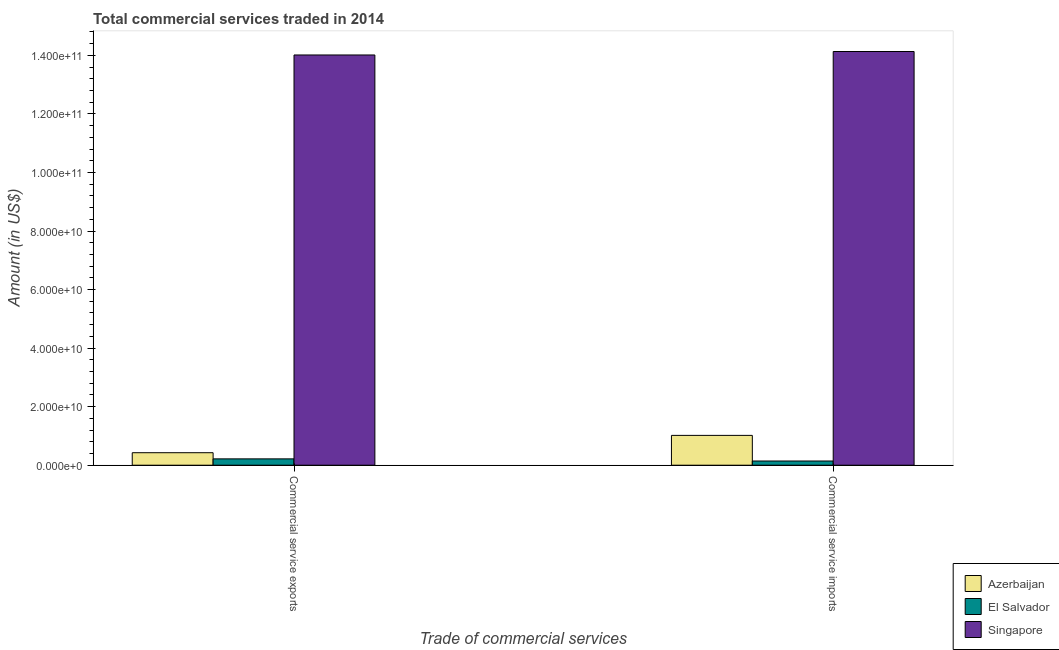How many different coloured bars are there?
Your answer should be compact. 3. Are the number of bars on each tick of the X-axis equal?
Your answer should be very brief. Yes. How many bars are there on the 1st tick from the right?
Your answer should be compact. 3. What is the label of the 2nd group of bars from the left?
Provide a succinct answer. Commercial service imports. What is the amount of commercial service imports in Azerbaijan?
Your answer should be very brief. 1.02e+1. Across all countries, what is the maximum amount of commercial service exports?
Ensure brevity in your answer.  1.40e+11. Across all countries, what is the minimum amount of commercial service exports?
Offer a terse response. 2.16e+09. In which country was the amount of commercial service imports maximum?
Offer a terse response. Singapore. In which country was the amount of commercial service exports minimum?
Ensure brevity in your answer.  El Salvador. What is the total amount of commercial service imports in the graph?
Keep it short and to the point. 1.53e+11. What is the difference between the amount of commercial service exports in El Salvador and that in Singapore?
Offer a very short reply. -1.38e+11. What is the difference between the amount of commercial service imports in Azerbaijan and the amount of commercial service exports in Singapore?
Your response must be concise. -1.30e+11. What is the average amount of commercial service imports per country?
Offer a very short reply. 5.10e+1. What is the difference between the amount of commercial service imports and amount of commercial service exports in Azerbaijan?
Offer a very short reply. 5.92e+09. What is the ratio of the amount of commercial service exports in El Salvador to that in Azerbaijan?
Give a very brief answer. 0.51. Is the amount of commercial service exports in Singapore less than that in El Salvador?
Ensure brevity in your answer.  No. What does the 3rd bar from the left in Commercial service exports represents?
Your answer should be very brief. Singapore. What does the 2nd bar from the right in Commercial service imports represents?
Provide a succinct answer. El Salvador. How many bars are there?
Provide a succinct answer. 6. What is the difference between two consecutive major ticks on the Y-axis?
Make the answer very short. 2.00e+1. Are the values on the major ticks of Y-axis written in scientific E-notation?
Make the answer very short. Yes. Does the graph contain grids?
Give a very brief answer. No. Where does the legend appear in the graph?
Your response must be concise. Bottom right. What is the title of the graph?
Your answer should be very brief. Total commercial services traded in 2014. What is the label or title of the X-axis?
Your answer should be compact. Trade of commercial services. What is the label or title of the Y-axis?
Offer a terse response. Amount (in US$). What is the Amount (in US$) in Azerbaijan in Commercial service exports?
Ensure brevity in your answer.  4.27e+09. What is the Amount (in US$) of El Salvador in Commercial service exports?
Offer a terse response. 2.16e+09. What is the Amount (in US$) of Singapore in Commercial service exports?
Your answer should be very brief. 1.40e+11. What is the Amount (in US$) of Azerbaijan in Commercial service imports?
Offer a terse response. 1.02e+1. What is the Amount (in US$) of El Salvador in Commercial service imports?
Your answer should be very brief. 1.43e+09. What is the Amount (in US$) in Singapore in Commercial service imports?
Offer a terse response. 1.41e+11. Across all Trade of commercial services, what is the maximum Amount (in US$) in Azerbaijan?
Keep it short and to the point. 1.02e+1. Across all Trade of commercial services, what is the maximum Amount (in US$) in El Salvador?
Ensure brevity in your answer.  2.16e+09. Across all Trade of commercial services, what is the maximum Amount (in US$) of Singapore?
Offer a very short reply. 1.41e+11. Across all Trade of commercial services, what is the minimum Amount (in US$) of Azerbaijan?
Provide a short and direct response. 4.27e+09. Across all Trade of commercial services, what is the minimum Amount (in US$) of El Salvador?
Make the answer very short. 1.43e+09. Across all Trade of commercial services, what is the minimum Amount (in US$) in Singapore?
Your response must be concise. 1.40e+11. What is the total Amount (in US$) of Azerbaijan in the graph?
Offer a terse response. 1.45e+1. What is the total Amount (in US$) of El Salvador in the graph?
Provide a succinct answer. 3.60e+09. What is the total Amount (in US$) in Singapore in the graph?
Provide a short and direct response. 2.81e+11. What is the difference between the Amount (in US$) in Azerbaijan in Commercial service exports and that in Commercial service imports?
Make the answer very short. -5.92e+09. What is the difference between the Amount (in US$) of El Salvador in Commercial service exports and that in Commercial service imports?
Make the answer very short. 7.31e+08. What is the difference between the Amount (in US$) in Singapore in Commercial service exports and that in Commercial service imports?
Your response must be concise. -1.18e+09. What is the difference between the Amount (in US$) in Azerbaijan in Commercial service exports and the Amount (in US$) in El Salvador in Commercial service imports?
Your answer should be compact. 2.83e+09. What is the difference between the Amount (in US$) of Azerbaijan in Commercial service exports and the Amount (in US$) of Singapore in Commercial service imports?
Your response must be concise. -1.37e+11. What is the difference between the Amount (in US$) of El Salvador in Commercial service exports and the Amount (in US$) of Singapore in Commercial service imports?
Ensure brevity in your answer.  -1.39e+11. What is the average Amount (in US$) of Azerbaijan per Trade of commercial services?
Your answer should be very brief. 7.23e+09. What is the average Amount (in US$) of El Salvador per Trade of commercial services?
Offer a terse response. 1.80e+09. What is the average Amount (in US$) of Singapore per Trade of commercial services?
Your answer should be very brief. 1.41e+11. What is the difference between the Amount (in US$) in Azerbaijan and Amount (in US$) in El Salvador in Commercial service exports?
Make the answer very short. 2.10e+09. What is the difference between the Amount (in US$) in Azerbaijan and Amount (in US$) in Singapore in Commercial service exports?
Provide a short and direct response. -1.36e+11. What is the difference between the Amount (in US$) in El Salvador and Amount (in US$) in Singapore in Commercial service exports?
Your answer should be compact. -1.38e+11. What is the difference between the Amount (in US$) in Azerbaijan and Amount (in US$) in El Salvador in Commercial service imports?
Ensure brevity in your answer.  8.75e+09. What is the difference between the Amount (in US$) in Azerbaijan and Amount (in US$) in Singapore in Commercial service imports?
Ensure brevity in your answer.  -1.31e+11. What is the difference between the Amount (in US$) of El Salvador and Amount (in US$) of Singapore in Commercial service imports?
Give a very brief answer. -1.40e+11. What is the ratio of the Amount (in US$) of Azerbaijan in Commercial service exports to that in Commercial service imports?
Make the answer very short. 0.42. What is the ratio of the Amount (in US$) of El Salvador in Commercial service exports to that in Commercial service imports?
Keep it short and to the point. 1.51. What is the difference between the highest and the second highest Amount (in US$) in Azerbaijan?
Provide a succinct answer. 5.92e+09. What is the difference between the highest and the second highest Amount (in US$) of El Salvador?
Ensure brevity in your answer.  7.31e+08. What is the difference between the highest and the second highest Amount (in US$) of Singapore?
Provide a succinct answer. 1.18e+09. What is the difference between the highest and the lowest Amount (in US$) in Azerbaijan?
Your response must be concise. 5.92e+09. What is the difference between the highest and the lowest Amount (in US$) of El Salvador?
Provide a succinct answer. 7.31e+08. What is the difference between the highest and the lowest Amount (in US$) in Singapore?
Offer a terse response. 1.18e+09. 